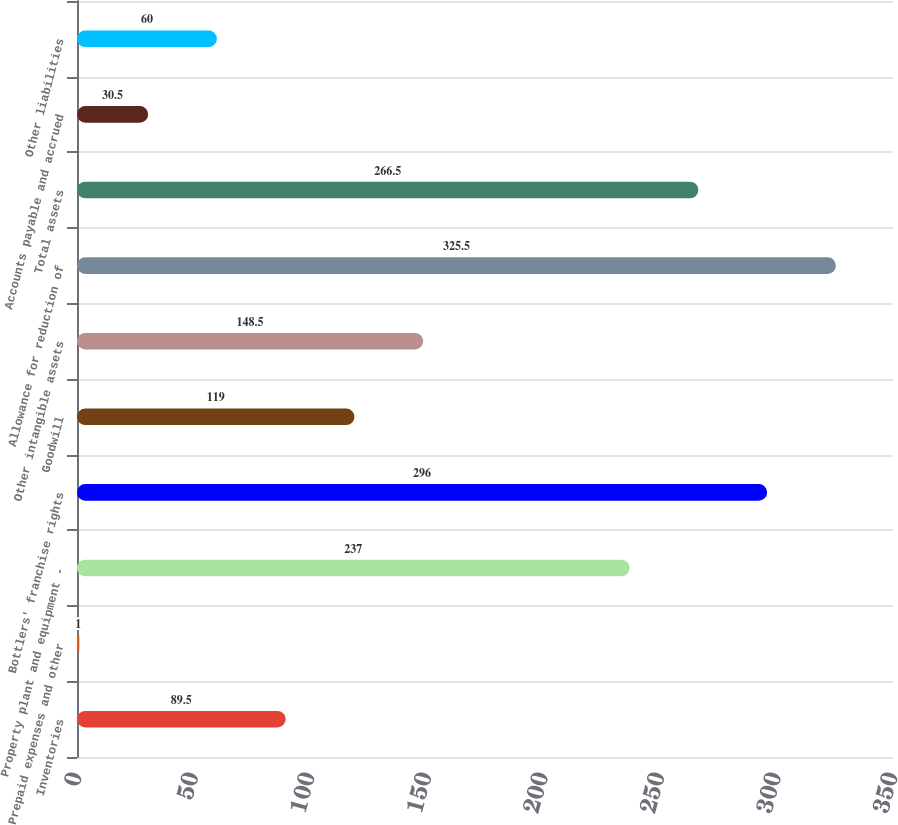Convert chart. <chart><loc_0><loc_0><loc_500><loc_500><bar_chart><fcel>Inventories<fcel>Prepaid expenses and other<fcel>Property plant and equipment -<fcel>Bottlers' franchise rights<fcel>Goodwill<fcel>Other intangible assets<fcel>Allowance for reduction of<fcel>Total assets<fcel>Accounts payable and accrued<fcel>Other liabilities<nl><fcel>89.5<fcel>1<fcel>237<fcel>296<fcel>119<fcel>148.5<fcel>325.5<fcel>266.5<fcel>30.5<fcel>60<nl></chart> 